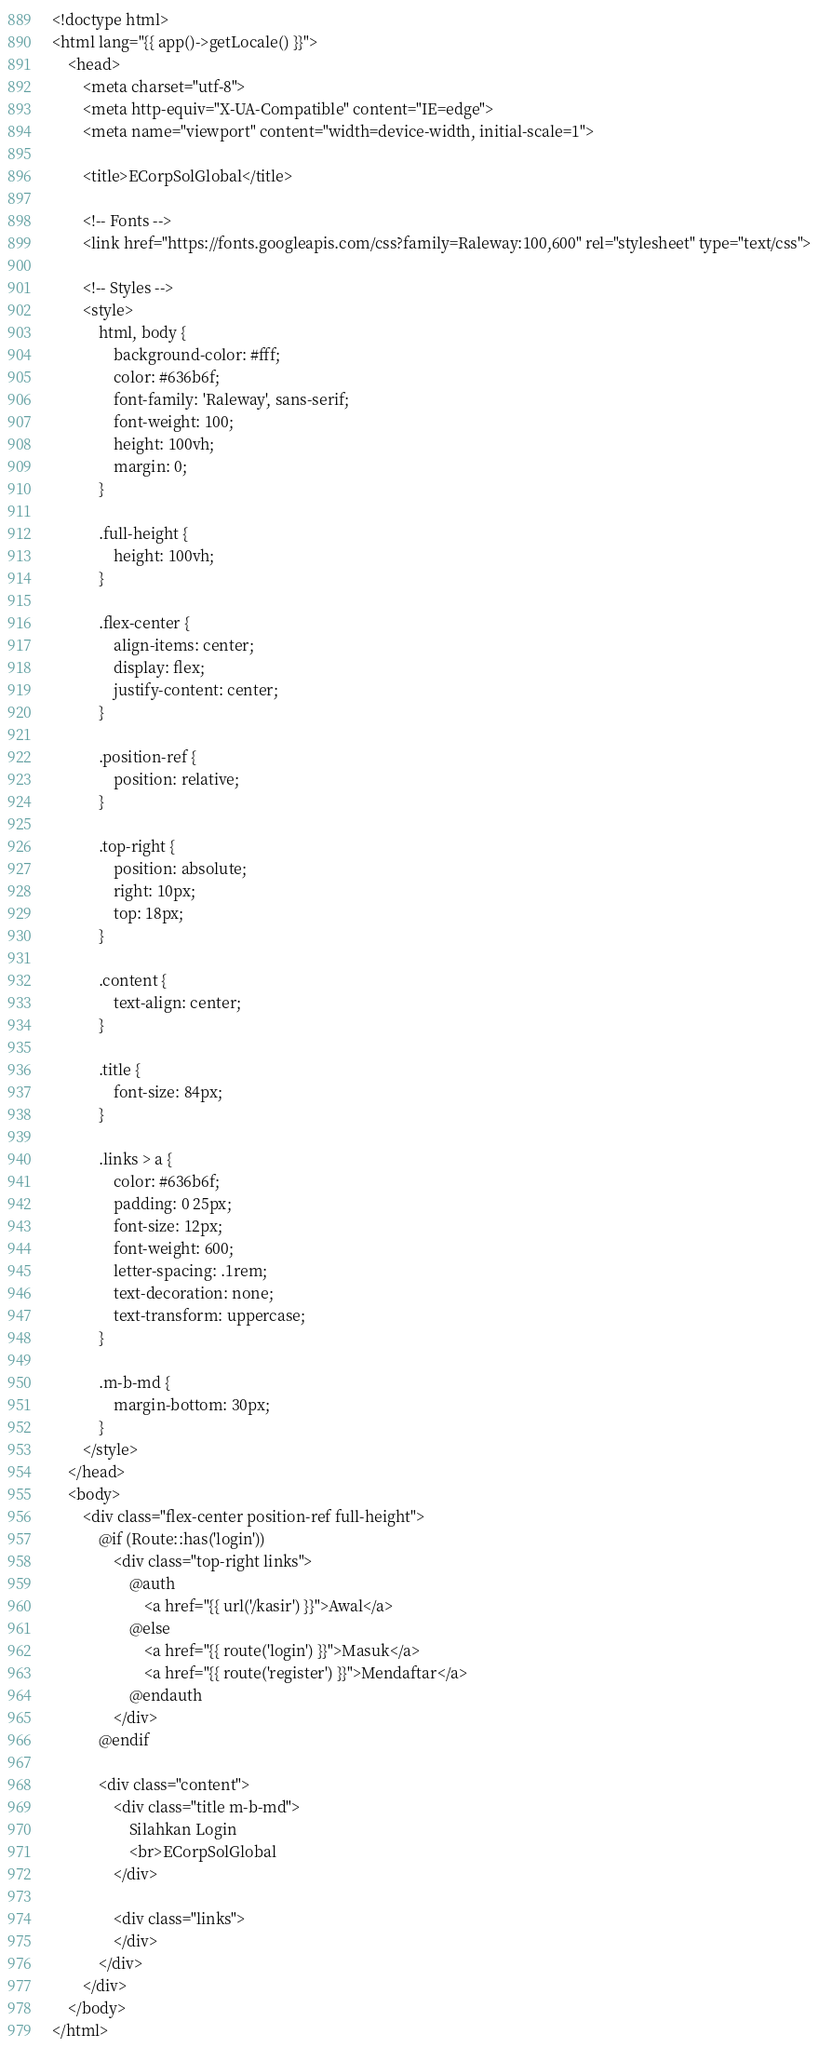Convert code to text. <code><loc_0><loc_0><loc_500><loc_500><_PHP_><!doctype html>
<html lang="{{ app()->getLocale() }}">
    <head>
        <meta charset="utf-8">
        <meta http-equiv="X-UA-Compatible" content="IE=edge">
        <meta name="viewport" content="width=device-width, initial-scale=1">

        <title>ECorpSolGlobal</title>

        <!-- Fonts -->
        <link href="https://fonts.googleapis.com/css?family=Raleway:100,600" rel="stylesheet" type="text/css">

        <!-- Styles -->
        <style>
            html, body {
                background-color: #fff;
                color: #636b6f;
                font-family: 'Raleway', sans-serif;
                font-weight: 100;
                height: 100vh;
                margin: 0;
            }

            .full-height {
                height: 100vh;
            }

            .flex-center {
                align-items: center;
                display: flex;
                justify-content: center;
            }

            .position-ref {
                position: relative;
            }

            .top-right {
                position: absolute;
                right: 10px;
                top: 18px;
            }

            .content {
                text-align: center;
            }

            .title {
                font-size: 84px;
            }

            .links > a {
                color: #636b6f;
                padding: 0 25px;
                font-size: 12px;
                font-weight: 600;
                letter-spacing: .1rem;
                text-decoration: none;
                text-transform: uppercase;
            }

            .m-b-md {
                margin-bottom: 30px;
            }
        </style>
    </head>
    <body>
        <div class="flex-center position-ref full-height">
            @if (Route::has('login'))
                <div class="top-right links">
                    @auth
                        <a href="{{ url('/kasir') }}">Awal</a>
                    @else
                        <a href="{{ route('login') }}">Masuk</a>
                        <a href="{{ route('register') }}">Mendaftar</a>
                    @endauth
                </div>
            @endif

            <div class="content">
                <div class="title m-b-md">
                    Silahkan Login
                    <br>ECorpSolGlobal
                </div>

                <div class="links">
                </div>
            </div>
        </div>
    </body>
</html>
</code> 